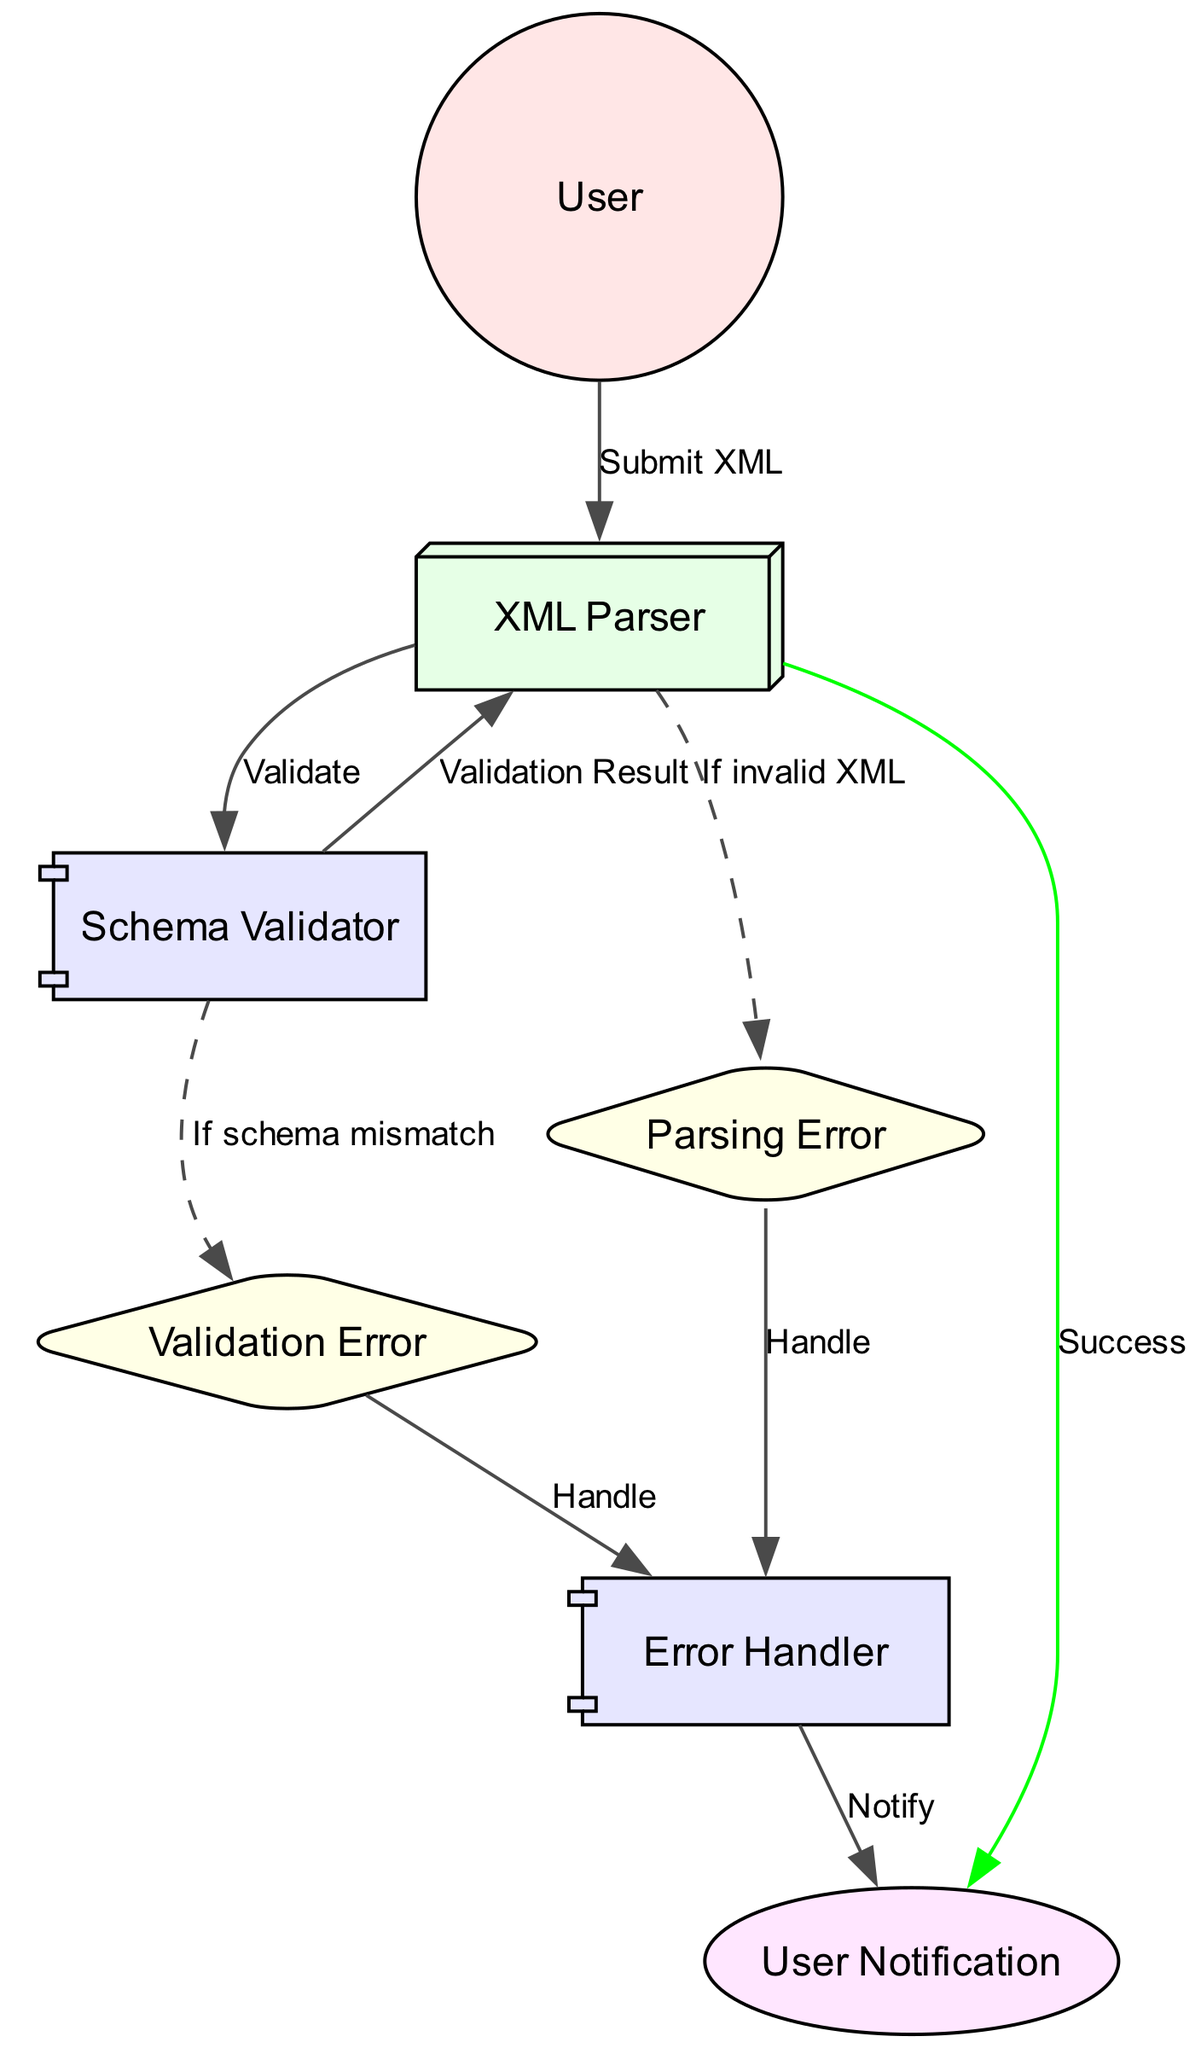What is the first action the User takes? The User starts the process by submitting an XML document to the XML Parser, which is the first action indicated in the sequence diagram.
Answer: Submit XML How many errors are represented in the diagram? There are two types of errors depicted: Parsing Error and Validation Error, making a total of two errors represented in the diagram.
Answer: Two What does the Schema Validator output? The Schema Validator outputs a "Validation Result" back to the XML Parser indicating the outcome of the schema validation.
Answer: Validation Result If the XML document is well-formed but not valid, which error is triggered? If the XML document is well-formed but not valid, the Parsing Error is triggered as highlighted by the dashed edge from the XML Parser to the Parsing Error node.
Answer: Parsing Error What component handles the errors? The Error Handler component is responsible for managing errors, as illustrated by the connections from both the Parsing Error and Validation Error to this component.
Answer: Error Handler What happens after the User Notification is sent? After the User Notification is sent, it indicates either a successful processing of the XML document or an error, concluding the sequence of actions.
Answer: Success or error notification What is the relationship between the XML Parser and the Schema Validator? The XML Parser sends a "Validate" action to the Schema Validator, which shows a direct connection representing the relationship in the sequence of operations.
Answer: Validate What type of edge connects the XML Parser to the Parsing Error? The edge connecting the XML Parser to the Parsing Error is dashed, indicating a conditional flow that represents an error state when a certain condition is met, specifically if the XML is invalid.
Answer: Dashed edge How does the User receive feedback? The user receives feedback through the User Notification process, which communicates either success or failure of the parsing and validation process.
Answer: User Notification 